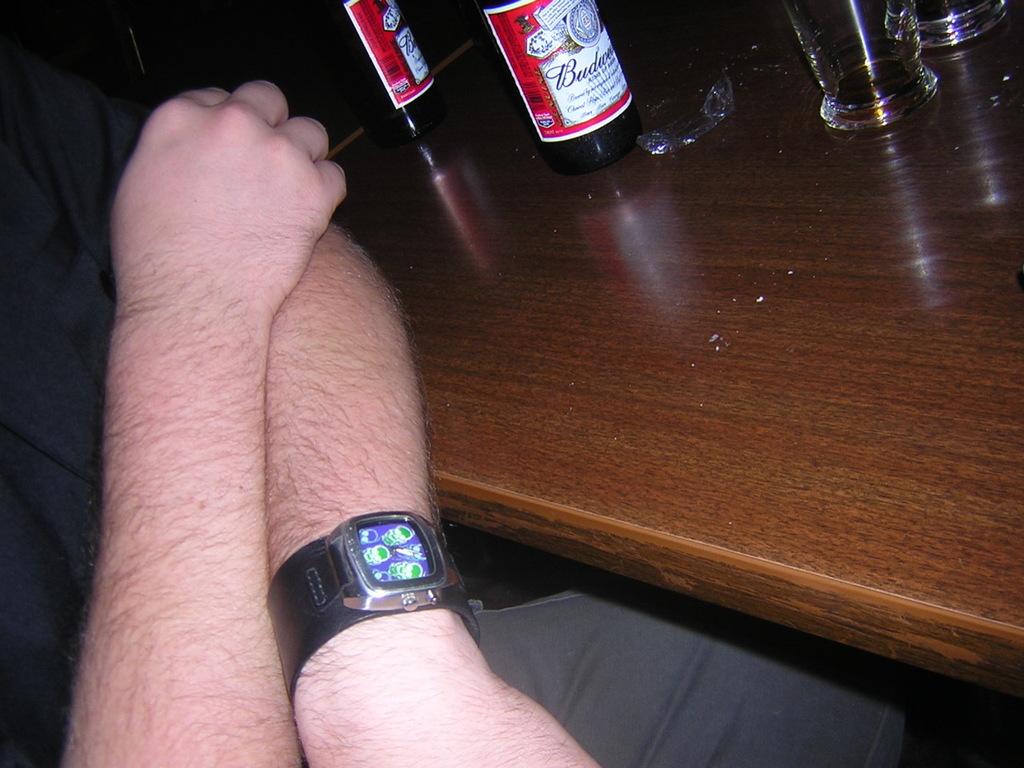What brand of beer is on the table?
Offer a very short reply. Budweiser. 